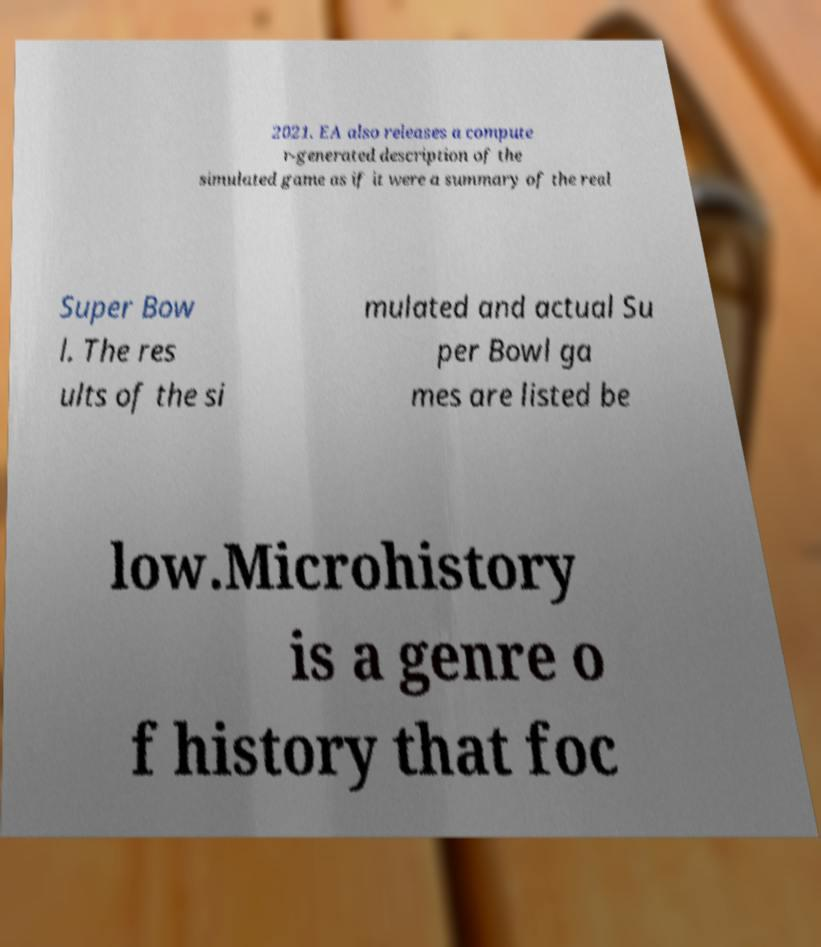Please read and relay the text visible in this image. What does it say? 2021. EA also releases a compute r-generated description of the simulated game as if it were a summary of the real Super Bow l. The res ults of the si mulated and actual Su per Bowl ga mes are listed be low.Microhistory is a genre o f history that foc 